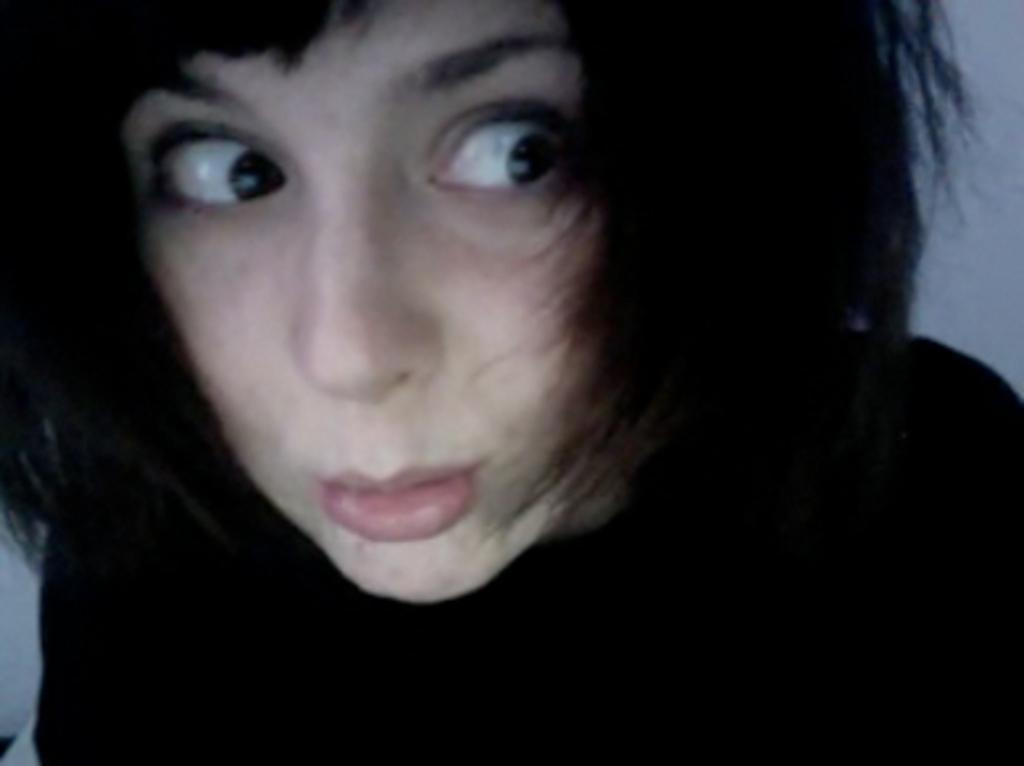What is present in the image? There is a person in the image. What is the person wearing? The person is wearing a black dress. What types of toys can be seen in the image? There are no toys present in the image; it only features a person wearing a black dress. 